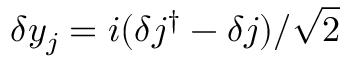Convert formula to latex. <formula><loc_0><loc_0><loc_500><loc_500>\delta y _ { j } = i ( \delta j ^ { \dagger } - \delta j ) / \sqrt { 2 }</formula> 